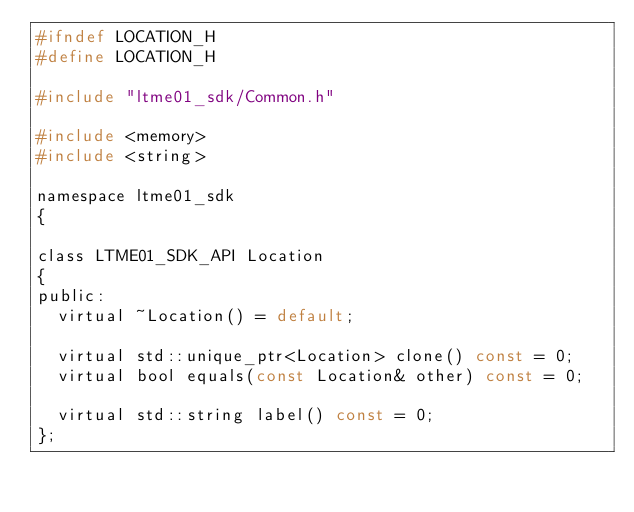<code> <loc_0><loc_0><loc_500><loc_500><_C_>#ifndef LOCATION_H
#define LOCATION_H

#include "ltme01_sdk/Common.h"

#include <memory>
#include <string>

namespace ltme01_sdk
{

class LTME01_SDK_API Location
{
public:
  virtual ~Location() = default;

  virtual std::unique_ptr<Location> clone() const = 0;
  virtual bool equals(const Location& other) const = 0;

  virtual std::string label() const = 0;
};
</code> 